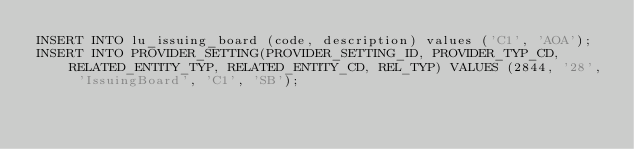Convert code to text. <code><loc_0><loc_0><loc_500><loc_500><_SQL_>INSERT INTO lu_issuing_board (code, description) values ('C1', 'AOA');
INSERT INTO PROVIDER_SETTING(PROVIDER_SETTING_ID, PROVIDER_TYP_CD, RELATED_ENTITY_TYP, RELATED_ENTITY_CD, REL_TYP) VALUES (2844, '28', 'IssuingBoard', 'C1', 'SB');</code> 